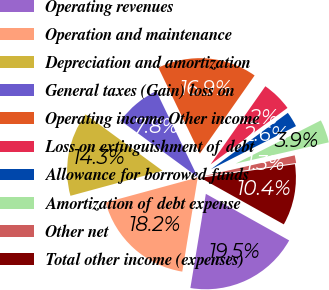<chart> <loc_0><loc_0><loc_500><loc_500><pie_chart><fcel>Operating revenues<fcel>Operation and maintenance<fcel>Depreciation and amortization<fcel>General taxes (Gain) loss on<fcel>Operating income Other income<fcel>Loss on extinguishment of debt<fcel>Allowance for borrowed funds<fcel>Amortization of debt expense<fcel>Other net<fcel>Total other income (expenses)<nl><fcel>19.48%<fcel>18.18%<fcel>14.29%<fcel>7.79%<fcel>16.88%<fcel>5.19%<fcel>2.6%<fcel>3.9%<fcel>1.3%<fcel>10.39%<nl></chart> 